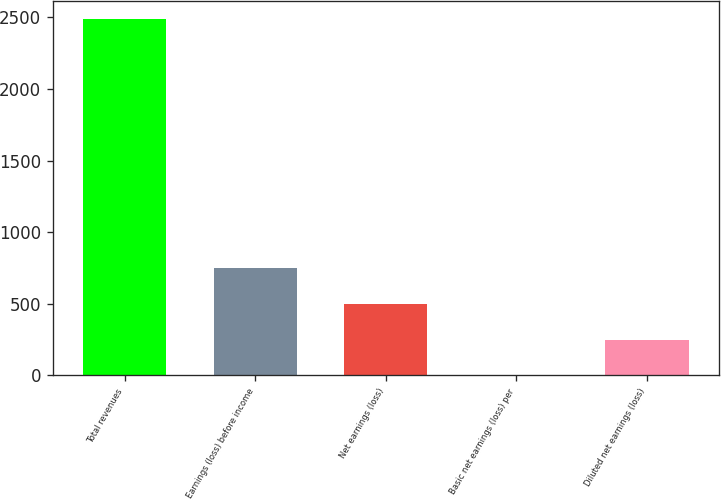Convert chart. <chart><loc_0><loc_0><loc_500><loc_500><bar_chart><fcel>Total revenues<fcel>Earnings (loss) before income<fcel>Net earnings (loss)<fcel>Basic net earnings (loss) per<fcel>Diluted net earnings (loss)<nl><fcel>2488<fcel>746.85<fcel>498.11<fcel>0.63<fcel>249.37<nl></chart> 